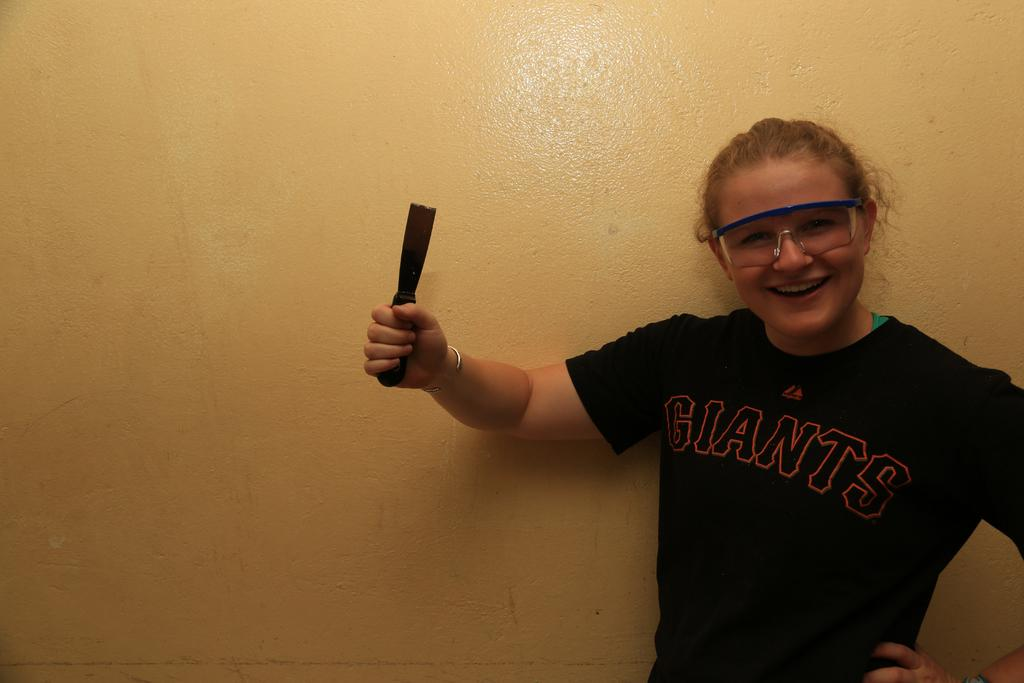What is the main subject of the image? There is a woman in the image. What is the woman doing in the image? The woman is standing in the image. What is the woman holding in her hand? The woman is holding an object in her hand. What type of watch is the woman wearing in the image? There is no watch visible in the image. The woman is not wearing a watch, and there is no mention of a watch in the provided facts. 